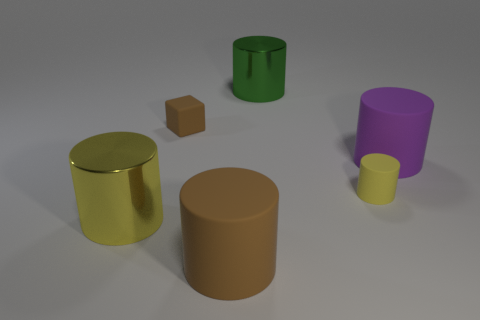Subtract 1 cylinders. How many cylinders are left? 4 Subtract all purple cylinders. Subtract all gray balls. How many cylinders are left? 4 Add 2 big green shiny cylinders. How many objects exist? 8 Subtract all cubes. How many objects are left? 5 Subtract 0 yellow cubes. How many objects are left? 6 Subtract all blocks. Subtract all small cylinders. How many objects are left? 4 Add 5 blocks. How many blocks are left? 6 Add 4 tiny cyan shiny objects. How many tiny cyan shiny objects exist? 4 